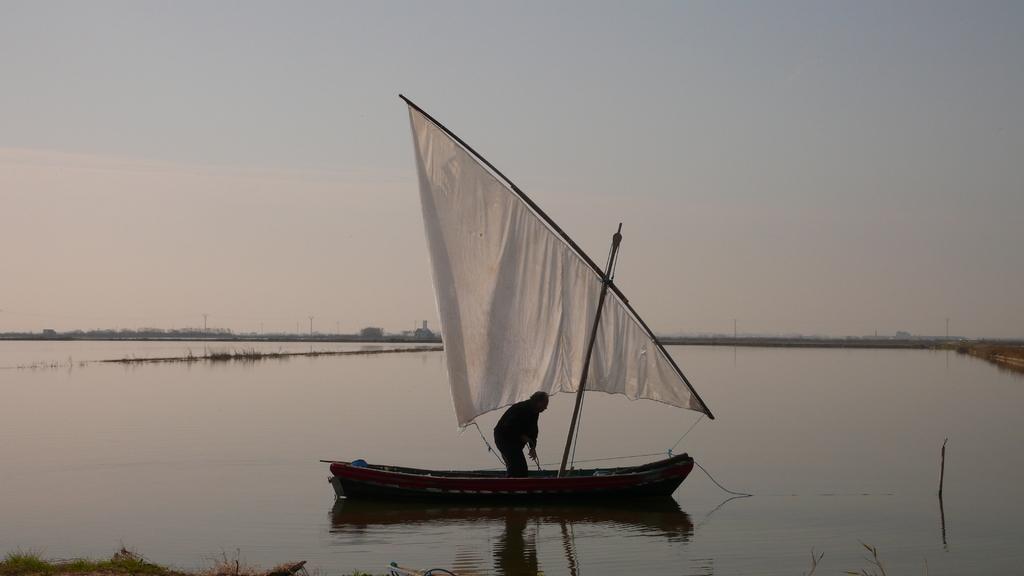Could you give a brief overview of what you see in this image? In this image we can see a person standing in a sailboat which is in a large water body. On the bottom of the image we can see some grass. On the backside we can see a group of buildings, poles and the sky which looks cloudy. 